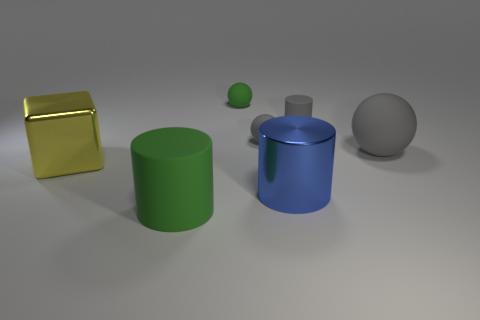Subtract all gray rubber cylinders. How many cylinders are left? 2 Subtract all yellow cubes. How many gray balls are left? 2 Add 1 large cyan metallic blocks. How many objects exist? 8 Subtract 1 cylinders. How many cylinders are left? 2 Subtract all red cylinders. Subtract all brown spheres. How many cylinders are left? 3 Subtract all balls. How many objects are left? 4 Add 3 metal cylinders. How many metal cylinders exist? 4 Subtract 1 gray spheres. How many objects are left? 6 Subtract all green metallic cubes. Subtract all large blue shiny cylinders. How many objects are left? 6 Add 5 blue objects. How many blue objects are left? 6 